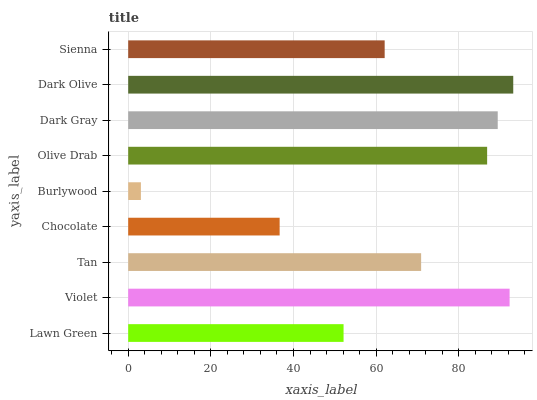Is Burlywood the minimum?
Answer yes or no. Yes. Is Dark Olive the maximum?
Answer yes or no. Yes. Is Violet the minimum?
Answer yes or no. No. Is Violet the maximum?
Answer yes or no. No. Is Violet greater than Lawn Green?
Answer yes or no. Yes. Is Lawn Green less than Violet?
Answer yes or no. Yes. Is Lawn Green greater than Violet?
Answer yes or no. No. Is Violet less than Lawn Green?
Answer yes or no. No. Is Tan the high median?
Answer yes or no. Yes. Is Tan the low median?
Answer yes or no. Yes. Is Dark Gray the high median?
Answer yes or no. No. Is Burlywood the low median?
Answer yes or no. No. 